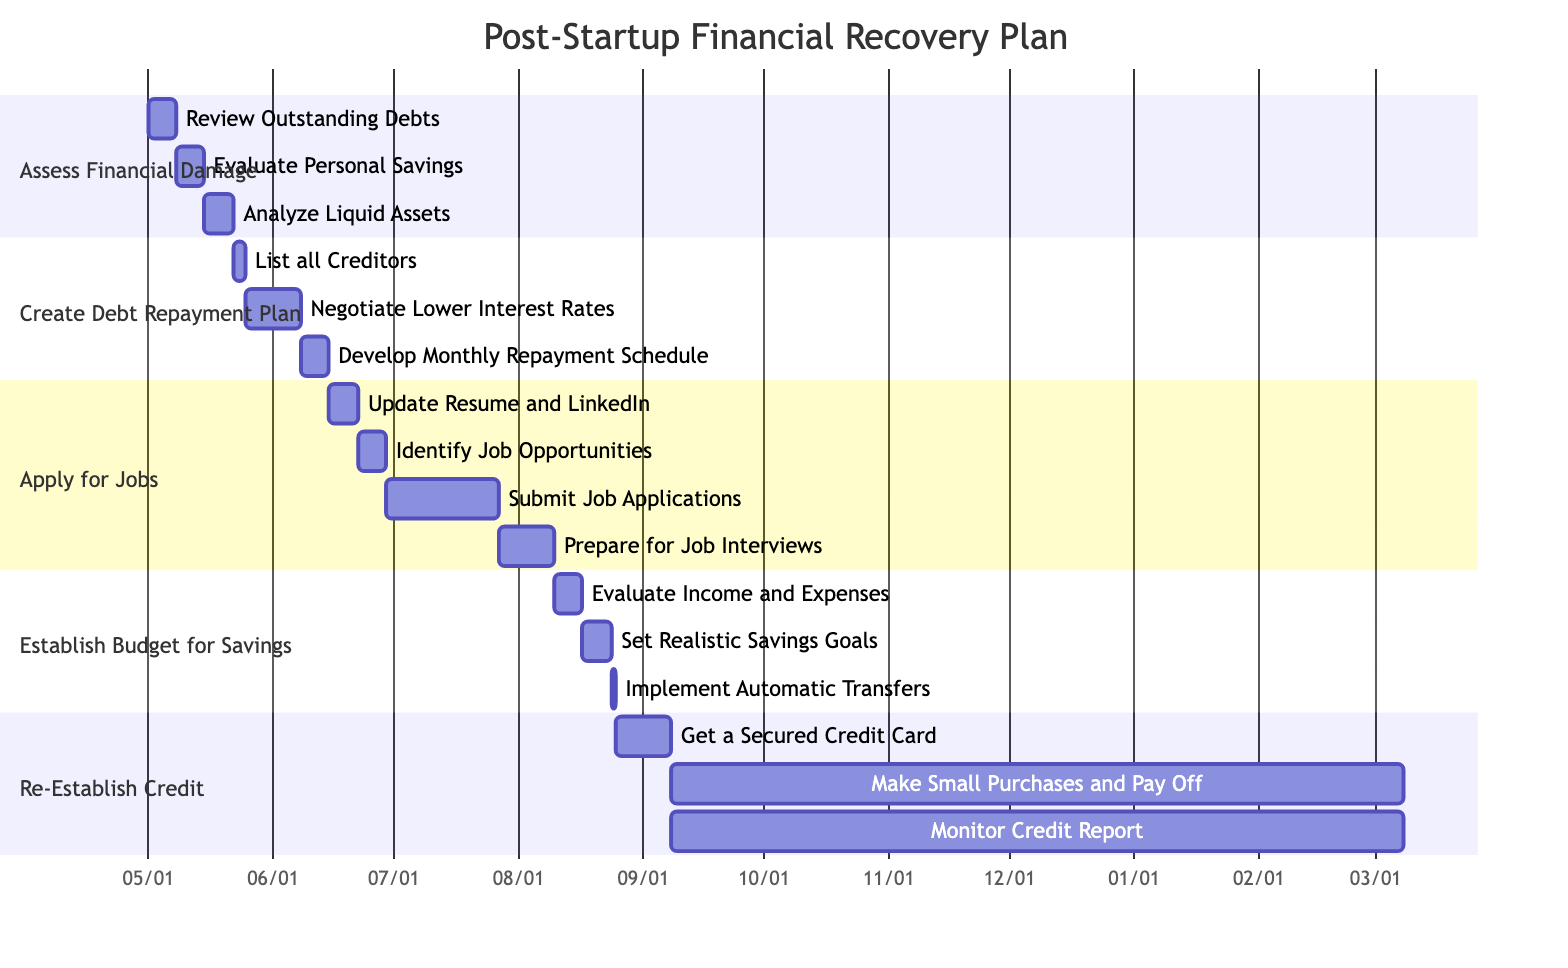What's the total number of main tasks in the Gantt Chart? The Gantt Chart has five main tasks represented as sections: Assess Financial Damage, Create Debt Repayment Plan, Apply for Jobs, Establish Budget for Savings, and Re-Establish Credit.
Answer: 5 Which task has the longest duration? The longest task is "Make Small, Regular Purchases and Pay Off Immediately" with a duration of six months, as it's indicated in the "Re-Establish Credit" section which spans from September 8 for 26 weeks.
Answer: six months What is the duration of the task "Create Debt Repayment Plan"? In the Gantt Chart, "Create Debt Repayment Plan" consists of three subtasks which are on different dates. The total duration is 4 weeks: 3 days + 2 weeks + 1 week, which equals approximately 4 weeks total.
Answer: 4 weeks What starts immediately after the task "Submit Job Applications"? After "Submit Job Applications," which lasts for four weeks, the next task is "Prepare for Job Interviews" which begins on July 27th, occurring right after July 29th.
Answer: Prepare for Job Interviews How many subtasks are in the task "Apply for Jobs"? The task "Apply for Jobs" includes four subtasks: Update Resume and LinkedIn Profile, Identify Job Opportunities, Submit Job Applications, and Prepare for Job Interviews. Each of these tasks is distinct and counts as a subtask.
Answer: 4 Which task follows "Evaluate Personal Savings"? Following the task "Evaluate Personal Savings," which takes one week, the next task is "Analyze Liquid Assets" starting one week later. This maintains the task order for "Assess Financial Damage."
Answer: Analyze Liquid Assets Identify the task that has an overlapping timeline with "Make Small, Regular Purchases and Pay Off Immediately". The task "Monitor Credit Report," which coincides with "Make Small, Regular Purchases and Pay Off Immediately" starting on the same day, extends over the same duration of six months.
Answer: Monitor Credit Report How many days does the task "List all Creditors" take? The task "List all Creditors" is scheduled for completion in three days as indicated in the Gantt Chart.
Answer: 3 days What is the immediate follow-up task after "Get a Secured Credit Card"? Following "Get a Secured Credit Card," which lasts for two weeks, the next tasks are "Make Small, Regular Purchases and Pay Off Immediately" and "Monitor Credit Report," both starting on September 8.
Answer: Make Small, Regular Purchases and Pay Off 